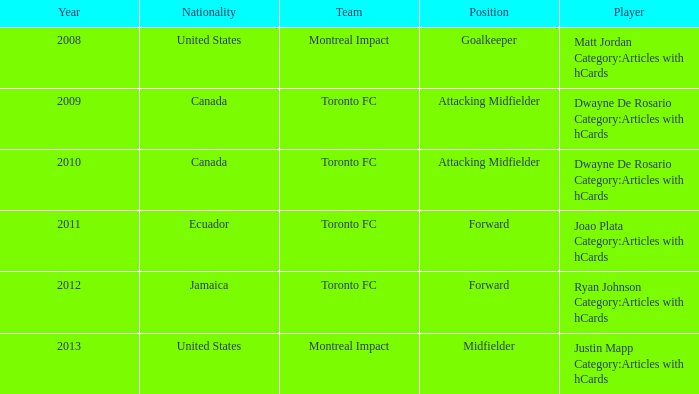After 2009, what's the nationality of a player named Dwayne de Rosario Category:articles with hcards? Canada. 